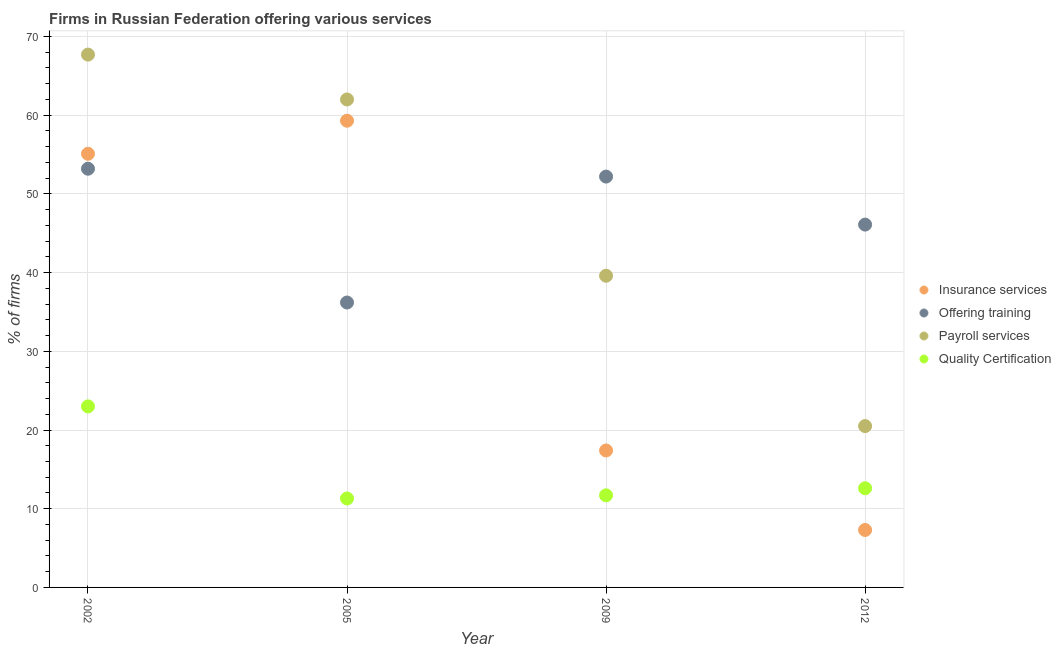How many different coloured dotlines are there?
Your answer should be compact. 4. What is the percentage of firms offering training in 2012?
Make the answer very short. 46.1. Across all years, what is the maximum percentage of firms offering quality certification?
Offer a terse response. 23. Across all years, what is the minimum percentage of firms offering training?
Offer a terse response. 36.2. In which year was the percentage of firms offering insurance services maximum?
Keep it short and to the point. 2005. What is the total percentage of firms offering payroll services in the graph?
Make the answer very short. 189.8. What is the difference between the percentage of firms offering insurance services in 2002 and that in 2012?
Provide a short and direct response. 47.8. What is the difference between the percentage of firms offering payroll services in 2005 and the percentage of firms offering insurance services in 2009?
Provide a succinct answer. 44.6. What is the average percentage of firms offering training per year?
Offer a very short reply. 46.93. In the year 2009, what is the difference between the percentage of firms offering quality certification and percentage of firms offering insurance services?
Your answer should be compact. -5.7. What is the ratio of the percentage of firms offering quality certification in 2005 to that in 2009?
Keep it short and to the point. 0.97. What is the difference between the highest and the second highest percentage of firms offering training?
Give a very brief answer. 1. What is the difference between the highest and the lowest percentage of firms offering insurance services?
Offer a terse response. 52. Is it the case that in every year, the sum of the percentage of firms offering insurance services and percentage of firms offering training is greater than the sum of percentage of firms offering quality certification and percentage of firms offering payroll services?
Ensure brevity in your answer.  No. Is it the case that in every year, the sum of the percentage of firms offering insurance services and percentage of firms offering training is greater than the percentage of firms offering payroll services?
Make the answer very short. Yes. Does the percentage of firms offering quality certification monotonically increase over the years?
Provide a short and direct response. No. Is the percentage of firms offering payroll services strictly less than the percentage of firms offering training over the years?
Provide a succinct answer. No. What is the difference between two consecutive major ticks on the Y-axis?
Offer a very short reply. 10. Does the graph contain any zero values?
Offer a very short reply. No. How many legend labels are there?
Your response must be concise. 4. What is the title of the graph?
Your response must be concise. Firms in Russian Federation offering various services . Does "Third 20% of population" appear as one of the legend labels in the graph?
Make the answer very short. No. What is the label or title of the Y-axis?
Ensure brevity in your answer.  % of firms. What is the % of firms of Insurance services in 2002?
Make the answer very short. 55.1. What is the % of firms in Offering training in 2002?
Your answer should be compact. 53.2. What is the % of firms in Payroll services in 2002?
Ensure brevity in your answer.  67.7. What is the % of firms in Insurance services in 2005?
Make the answer very short. 59.3. What is the % of firms in Offering training in 2005?
Provide a succinct answer. 36.2. What is the % of firms of Payroll services in 2005?
Make the answer very short. 62. What is the % of firms of Quality Certification in 2005?
Offer a very short reply. 11.3. What is the % of firms of Insurance services in 2009?
Your response must be concise. 17.4. What is the % of firms in Offering training in 2009?
Give a very brief answer. 52.2. What is the % of firms of Payroll services in 2009?
Your response must be concise. 39.6. What is the % of firms of Quality Certification in 2009?
Provide a short and direct response. 11.7. What is the % of firms of Offering training in 2012?
Your answer should be compact. 46.1. What is the % of firms of Quality Certification in 2012?
Make the answer very short. 12.6. Across all years, what is the maximum % of firms in Insurance services?
Offer a terse response. 59.3. Across all years, what is the maximum % of firms of Offering training?
Your response must be concise. 53.2. Across all years, what is the maximum % of firms of Payroll services?
Your answer should be compact. 67.7. Across all years, what is the maximum % of firms of Quality Certification?
Your answer should be very brief. 23. Across all years, what is the minimum % of firms in Insurance services?
Your response must be concise. 7.3. Across all years, what is the minimum % of firms in Offering training?
Offer a very short reply. 36.2. Across all years, what is the minimum % of firms of Payroll services?
Your response must be concise. 20.5. What is the total % of firms in Insurance services in the graph?
Keep it short and to the point. 139.1. What is the total % of firms of Offering training in the graph?
Ensure brevity in your answer.  187.7. What is the total % of firms of Payroll services in the graph?
Offer a terse response. 189.8. What is the total % of firms in Quality Certification in the graph?
Keep it short and to the point. 58.6. What is the difference between the % of firms in Insurance services in 2002 and that in 2009?
Offer a terse response. 37.7. What is the difference between the % of firms in Offering training in 2002 and that in 2009?
Your response must be concise. 1. What is the difference between the % of firms in Payroll services in 2002 and that in 2009?
Your answer should be very brief. 28.1. What is the difference between the % of firms of Insurance services in 2002 and that in 2012?
Your response must be concise. 47.8. What is the difference between the % of firms in Payroll services in 2002 and that in 2012?
Make the answer very short. 47.2. What is the difference between the % of firms of Insurance services in 2005 and that in 2009?
Make the answer very short. 41.9. What is the difference between the % of firms in Payroll services in 2005 and that in 2009?
Your response must be concise. 22.4. What is the difference between the % of firms in Insurance services in 2005 and that in 2012?
Offer a terse response. 52. What is the difference between the % of firms of Payroll services in 2005 and that in 2012?
Your answer should be very brief. 41.5. What is the difference between the % of firms of Quality Certification in 2005 and that in 2012?
Offer a terse response. -1.3. What is the difference between the % of firms in Insurance services in 2009 and that in 2012?
Keep it short and to the point. 10.1. What is the difference between the % of firms in Offering training in 2009 and that in 2012?
Provide a succinct answer. 6.1. What is the difference between the % of firms of Insurance services in 2002 and the % of firms of Quality Certification in 2005?
Your answer should be very brief. 43.8. What is the difference between the % of firms in Offering training in 2002 and the % of firms in Payroll services in 2005?
Your answer should be compact. -8.8. What is the difference between the % of firms in Offering training in 2002 and the % of firms in Quality Certification in 2005?
Keep it short and to the point. 41.9. What is the difference between the % of firms in Payroll services in 2002 and the % of firms in Quality Certification in 2005?
Offer a terse response. 56.4. What is the difference between the % of firms in Insurance services in 2002 and the % of firms in Offering training in 2009?
Your answer should be very brief. 2.9. What is the difference between the % of firms of Insurance services in 2002 and the % of firms of Payroll services in 2009?
Your response must be concise. 15.5. What is the difference between the % of firms of Insurance services in 2002 and the % of firms of Quality Certification in 2009?
Your response must be concise. 43.4. What is the difference between the % of firms in Offering training in 2002 and the % of firms in Quality Certification in 2009?
Give a very brief answer. 41.5. What is the difference between the % of firms in Payroll services in 2002 and the % of firms in Quality Certification in 2009?
Keep it short and to the point. 56. What is the difference between the % of firms of Insurance services in 2002 and the % of firms of Payroll services in 2012?
Your answer should be very brief. 34.6. What is the difference between the % of firms of Insurance services in 2002 and the % of firms of Quality Certification in 2012?
Your answer should be compact. 42.5. What is the difference between the % of firms of Offering training in 2002 and the % of firms of Payroll services in 2012?
Ensure brevity in your answer.  32.7. What is the difference between the % of firms of Offering training in 2002 and the % of firms of Quality Certification in 2012?
Provide a succinct answer. 40.6. What is the difference between the % of firms in Payroll services in 2002 and the % of firms in Quality Certification in 2012?
Offer a very short reply. 55.1. What is the difference between the % of firms of Insurance services in 2005 and the % of firms of Offering training in 2009?
Ensure brevity in your answer.  7.1. What is the difference between the % of firms of Insurance services in 2005 and the % of firms of Payroll services in 2009?
Offer a terse response. 19.7. What is the difference between the % of firms of Insurance services in 2005 and the % of firms of Quality Certification in 2009?
Your answer should be compact. 47.6. What is the difference between the % of firms of Payroll services in 2005 and the % of firms of Quality Certification in 2009?
Keep it short and to the point. 50.3. What is the difference between the % of firms in Insurance services in 2005 and the % of firms in Payroll services in 2012?
Provide a short and direct response. 38.8. What is the difference between the % of firms in Insurance services in 2005 and the % of firms in Quality Certification in 2012?
Your answer should be compact. 46.7. What is the difference between the % of firms of Offering training in 2005 and the % of firms of Quality Certification in 2012?
Make the answer very short. 23.6. What is the difference between the % of firms in Payroll services in 2005 and the % of firms in Quality Certification in 2012?
Offer a very short reply. 49.4. What is the difference between the % of firms of Insurance services in 2009 and the % of firms of Offering training in 2012?
Your answer should be very brief. -28.7. What is the difference between the % of firms in Offering training in 2009 and the % of firms in Payroll services in 2012?
Provide a short and direct response. 31.7. What is the difference between the % of firms in Offering training in 2009 and the % of firms in Quality Certification in 2012?
Make the answer very short. 39.6. What is the difference between the % of firms of Payroll services in 2009 and the % of firms of Quality Certification in 2012?
Your answer should be very brief. 27. What is the average % of firms of Insurance services per year?
Your answer should be very brief. 34.77. What is the average % of firms of Offering training per year?
Provide a short and direct response. 46.92. What is the average % of firms of Payroll services per year?
Make the answer very short. 47.45. What is the average % of firms in Quality Certification per year?
Provide a succinct answer. 14.65. In the year 2002, what is the difference between the % of firms in Insurance services and % of firms in Offering training?
Provide a succinct answer. 1.9. In the year 2002, what is the difference between the % of firms of Insurance services and % of firms of Payroll services?
Provide a short and direct response. -12.6. In the year 2002, what is the difference between the % of firms in Insurance services and % of firms in Quality Certification?
Provide a short and direct response. 32.1. In the year 2002, what is the difference between the % of firms of Offering training and % of firms of Quality Certification?
Your answer should be compact. 30.2. In the year 2002, what is the difference between the % of firms in Payroll services and % of firms in Quality Certification?
Your answer should be compact. 44.7. In the year 2005, what is the difference between the % of firms in Insurance services and % of firms in Offering training?
Offer a very short reply. 23.1. In the year 2005, what is the difference between the % of firms in Insurance services and % of firms in Payroll services?
Offer a terse response. -2.7. In the year 2005, what is the difference between the % of firms of Offering training and % of firms of Payroll services?
Keep it short and to the point. -25.8. In the year 2005, what is the difference between the % of firms in Offering training and % of firms in Quality Certification?
Provide a succinct answer. 24.9. In the year 2005, what is the difference between the % of firms of Payroll services and % of firms of Quality Certification?
Offer a terse response. 50.7. In the year 2009, what is the difference between the % of firms in Insurance services and % of firms in Offering training?
Keep it short and to the point. -34.8. In the year 2009, what is the difference between the % of firms in Insurance services and % of firms in Payroll services?
Your answer should be very brief. -22.2. In the year 2009, what is the difference between the % of firms in Insurance services and % of firms in Quality Certification?
Keep it short and to the point. 5.7. In the year 2009, what is the difference between the % of firms in Offering training and % of firms in Quality Certification?
Offer a terse response. 40.5. In the year 2009, what is the difference between the % of firms of Payroll services and % of firms of Quality Certification?
Your response must be concise. 27.9. In the year 2012, what is the difference between the % of firms of Insurance services and % of firms of Offering training?
Ensure brevity in your answer.  -38.8. In the year 2012, what is the difference between the % of firms in Insurance services and % of firms in Quality Certification?
Make the answer very short. -5.3. In the year 2012, what is the difference between the % of firms in Offering training and % of firms in Payroll services?
Your answer should be compact. 25.6. In the year 2012, what is the difference between the % of firms in Offering training and % of firms in Quality Certification?
Offer a very short reply. 33.5. In the year 2012, what is the difference between the % of firms of Payroll services and % of firms of Quality Certification?
Your answer should be very brief. 7.9. What is the ratio of the % of firms of Insurance services in 2002 to that in 2005?
Your response must be concise. 0.93. What is the ratio of the % of firms of Offering training in 2002 to that in 2005?
Your answer should be very brief. 1.47. What is the ratio of the % of firms in Payroll services in 2002 to that in 2005?
Make the answer very short. 1.09. What is the ratio of the % of firms of Quality Certification in 2002 to that in 2005?
Ensure brevity in your answer.  2.04. What is the ratio of the % of firms of Insurance services in 2002 to that in 2009?
Your answer should be compact. 3.17. What is the ratio of the % of firms of Offering training in 2002 to that in 2009?
Your answer should be very brief. 1.02. What is the ratio of the % of firms of Payroll services in 2002 to that in 2009?
Your response must be concise. 1.71. What is the ratio of the % of firms in Quality Certification in 2002 to that in 2009?
Make the answer very short. 1.97. What is the ratio of the % of firms in Insurance services in 2002 to that in 2012?
Make the answer very short. 7.55. What is the ratio of the % of firms in Offering training in 2002 to that in 2012?
Offer a terse response. 1.15. What is the ratio of the % of firms of Payroll services in 2002 to that in 2012?
Provide a succinct answer. 3.3. What is the ratio of the % of firms of Quality Certification in 2002 to that in 2012?
Your response must be concise. 1.83. What is the ratio of the % of firms in Insurance services in 2005 to that in 2009?
Your response must be concise. 3.41. What is the ratio of the % of firms of Offering training in 2005 to that in 2009?
Keep it short and to the point. 0.69. What is the ratio of the % of firms of Payroll services in 2005 to that in 2009?
Your response must be concise. 1.57. What is the ratio of the % of firms in Quality Certification in 2005 to that in 2009?
Offer a very short reply. 0.97. What is the ratio of the % of firms of Insurance services in 2005 to that in 2012?
Ensure brevity in your answer.  8.12. What is the ratio of the % of firms in Offering training in 2005 to that in 2012?
Ensure brevity in your answer.  0.79. What is the ratio of the % of firms of Payroll services in 2005 to that in 2012?
Provide a short and direct response. 3.02. What is the ratio of the % of firms in Quality Certification in 2005 to that in 2012?
Your answer should be compact. 0.9. What is the ratio of the % of firms in Insurance services in 2009 to that in 2012?
Your response must be concise. 2.38. What is the ratio of the % of firms of Offering training in 2009 to that in 2012?
Offer a very short reply. 1.13. What is the ratio of the % of firms of Payroll services in 2009 to that in 2012?
Offer a terse response. 1.93. What is the difference between the highest and the second highest % of firms of Payroll services?
Your answer should be very brief. 5.7. What is the difference between the highest and the lowest % of firms in Offering training?
Your response must be concise. 17. What is the difference between the highest and the lowest % of firms in Payroll services?
Your response must be concise. 47.2. 